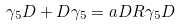<formula> <loc_0><loc_0><loc_500><loc_500>\gamma _ { 5 } D + D \gamma _ { 5 } = a D R \gamma _ { 5 } D</formula> 